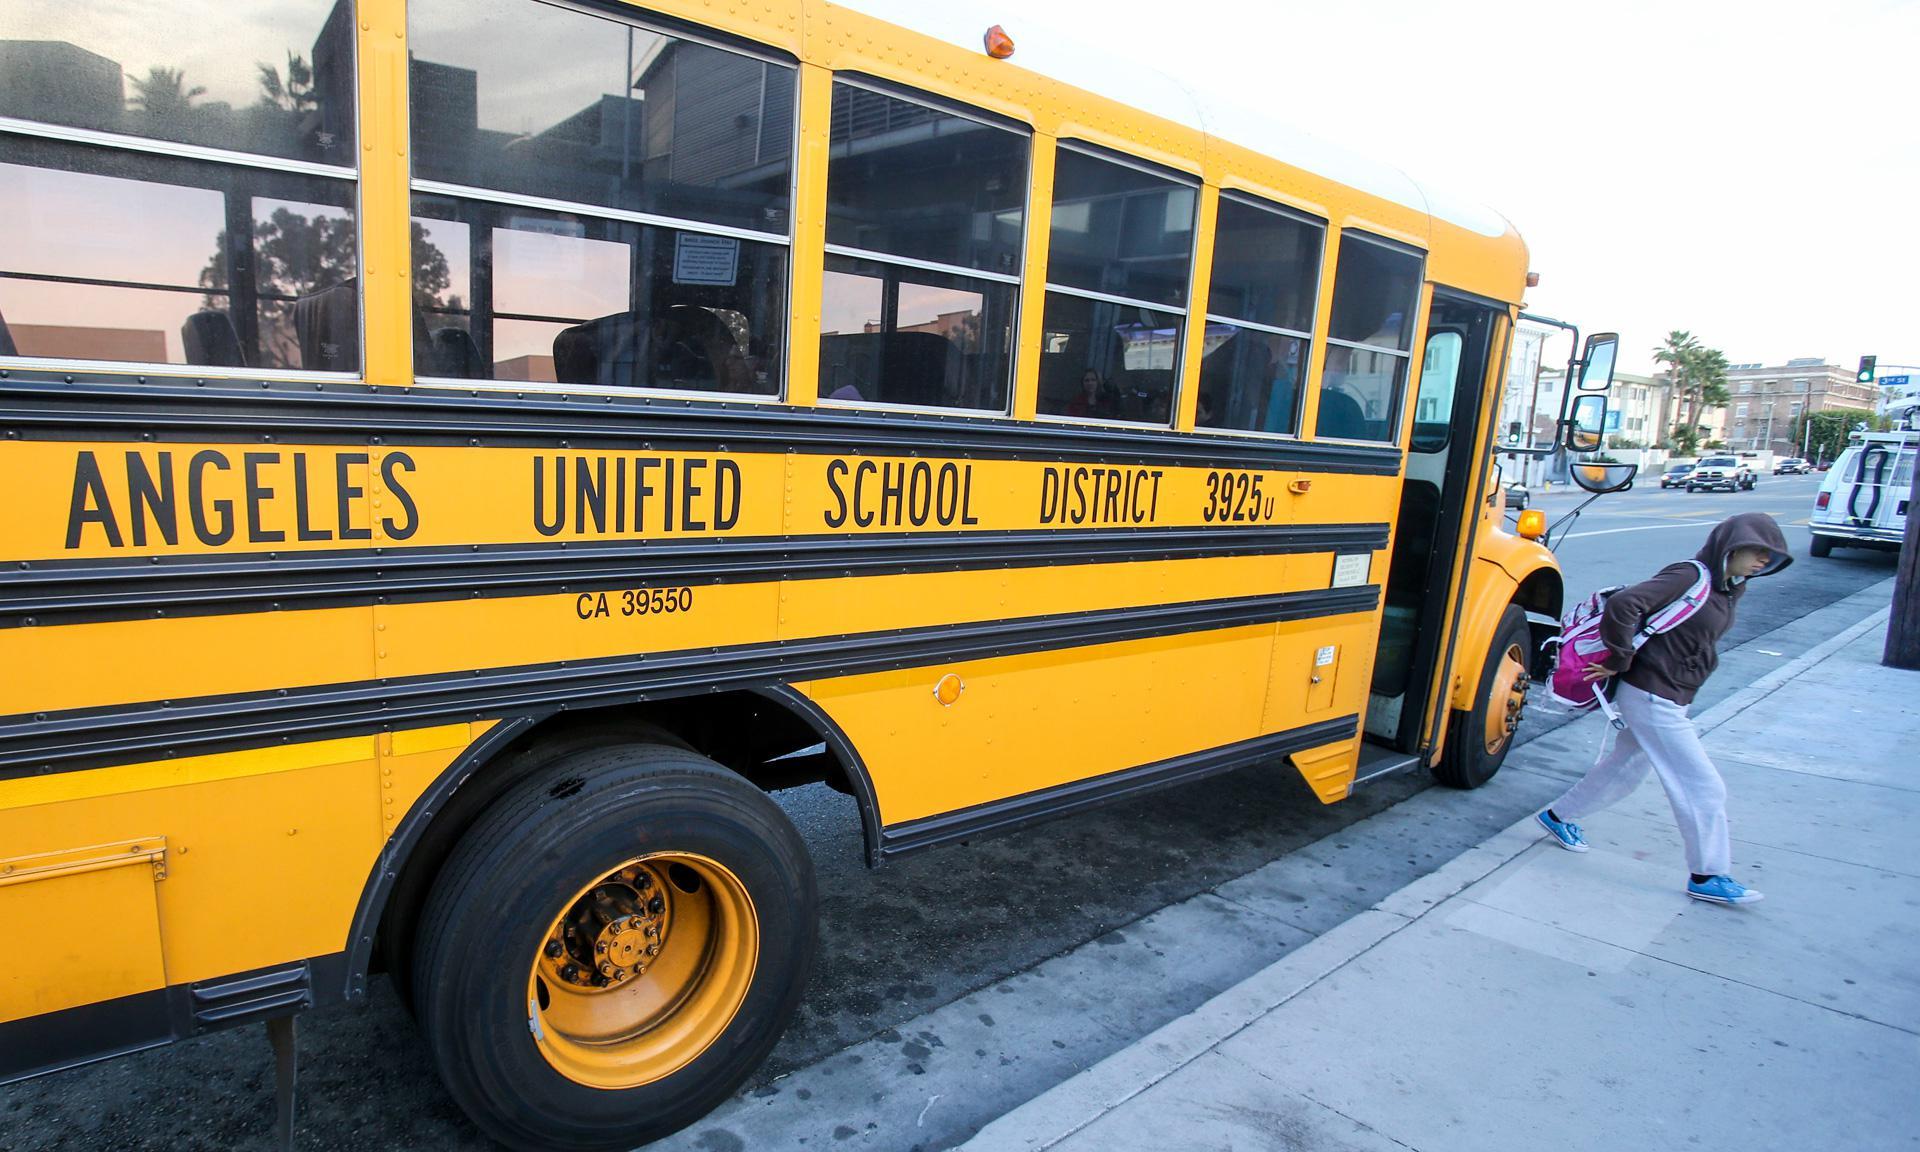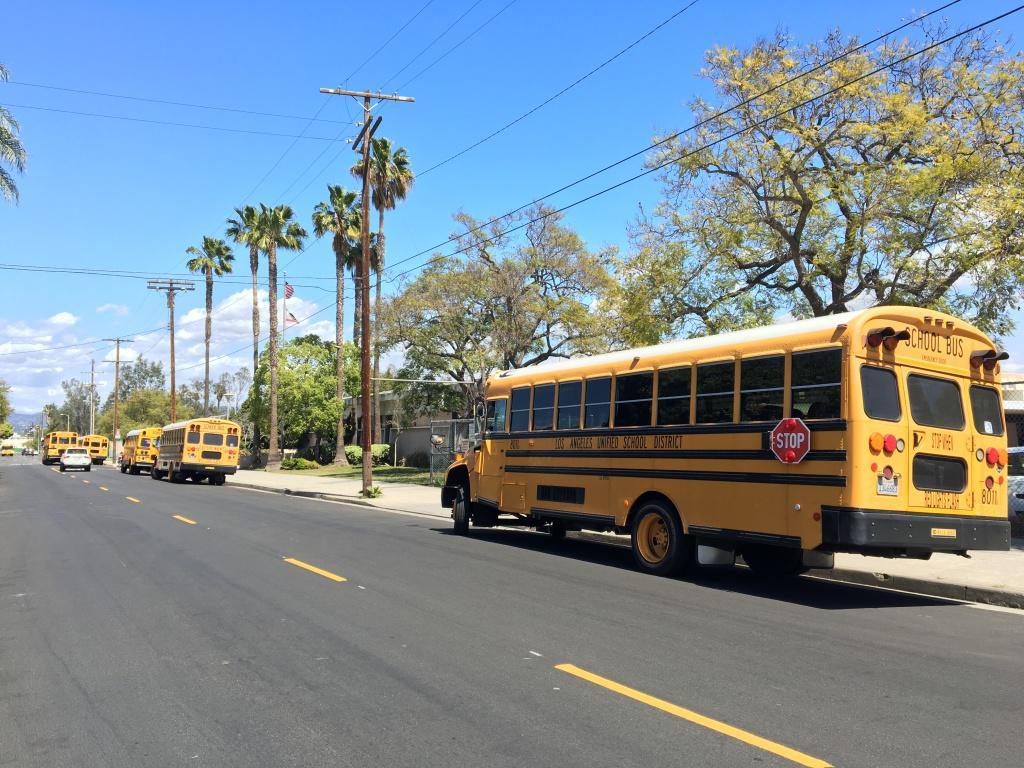The first image is the image on the left, the second image is the image on the right. For the images displayed, is the sentence "One image shows the back of three or more school buses parked at an angle, while a second image shows the front of one bus." factually correct? Answer yes or no. No. The first image is the image on the left, the second image is the image on the right. Analyze the images presented: Is the assertion "There are more buses in the image on the right." valid? Answer yes or no. Yes. 